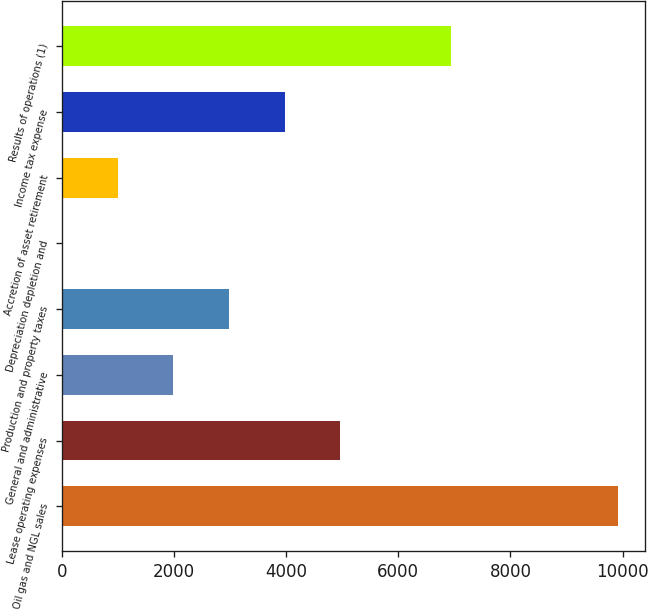Convert chart. <chart><loc_0><loc_0><loc_500><loc_500><bar_chart><fcel>Oil gas and NGL sales<fcel>Lease operating expenses<fcel>General and administrative<fcel>Production and property taxes<fcel>Depreciation depletion and<fcel>Accretion of asset retirement<fcel>Income tax expense<fcel>Results of operations (1)<nl><fcel>9910<fcel>4960.89<fcel>1991.43<fcel>2981.25<fcel>11.79<fcel>1001.61<fcel>3971.07<fcel>6940.53<nl></chart> 